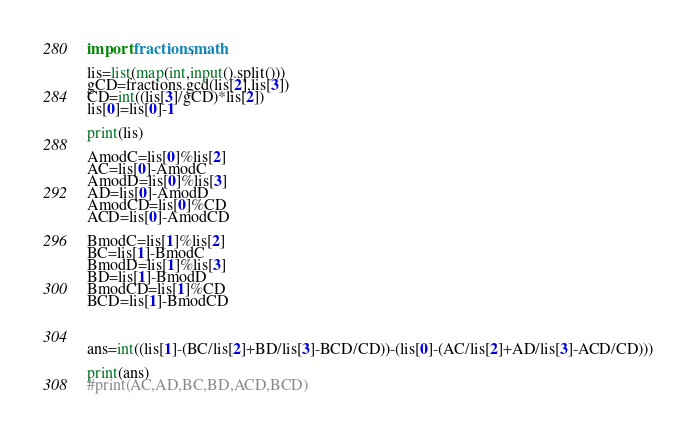<code> <loc_0><loc_0><loc_500><loc_500><_Python_>import fractions,math

lis=list(map(int,input().split()))
gCD=fractions.gcd(lis[2],lis[3])
CD=int((lis[3]/gCD)*lis[2])
lis[0]=lis[0]-1

print(lis)

AmodC=lis[0]%lis[2]
AC=lis[0]-AmodC
AmodD=lis[0]%lis[3]
AD=lis[0]-AmodD
AmodCD=lis[0]%CD
ACD=lis[0]-AmodCD

BmodC=lis[1]%lis[2]
BC=lis[1]-BmodC
BmodD=lis[1]%lis[3]
BD=lis[1]-BmodD
BmodCD=lis[1]%CD
BCD=lis[1]-BmodCD



ans=int((lis[1]-(BC/lis[2]+BD/lis[3]-BCD/CD))-(lis[0]-(AC/lis[2]+AD/lis[3]-ACD/CD)))

print(ans)
#print(AC,AD,BC,BD,ACD,BCD)
</code> 